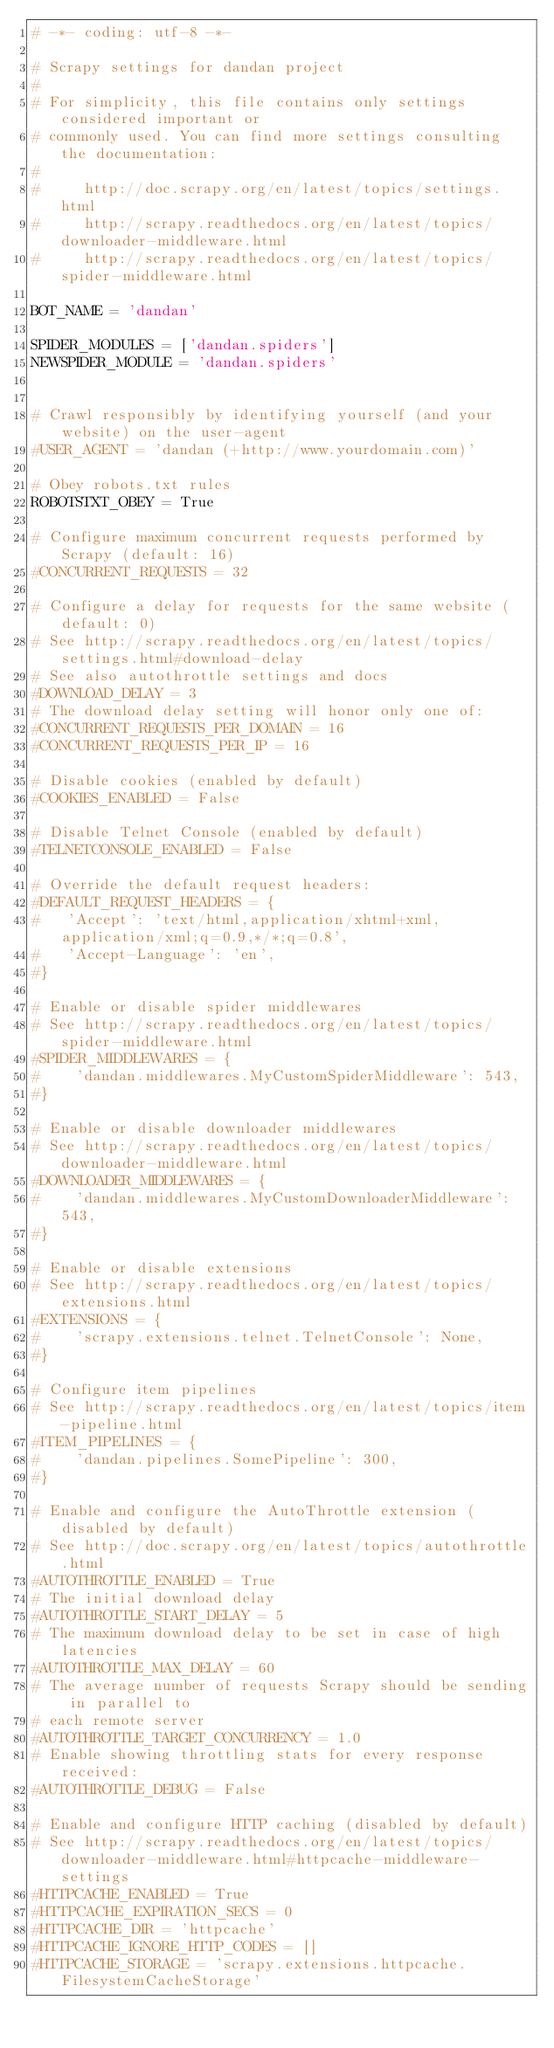Convert code to text. <code><loc_0><loc_0><loc_500><loc_500><_Python_># -*- coding: utf-8 -*-

# Scrapy settings for dandan project
#
# For simplicity, this file contains only settings considered important or
# commonly used. You can find more settings consulting the documentation:
#
#     http://doc.scrapy.org/en/latest/topics/settings.html
#     http://scrapy.readthedocs.org/en/latest/topics/downloader-middleware.html
#     http://scrapy.readthedocs.org/en/latest/topics/spider-middleware.html

BOT_NAME = 'dandan'

SPIDER_MODULES = ['dandan.spiders']
NEWSPIDER_MODULE = 'dandan.spiders'


# Crawl responsibly by identifying yourself (and your website) on the user-agent
#USER_AGENT = 'dandan (+http://www.yourdomain.com)'

# Obey robots.txt rules
ROBOTSTXT_OBEY = True

# Configure maximum concurrent requests performed by Scrapy (default: 16)
#CONCURRENT_REQUESTS = 32

# Configure a delay for requests for the same website (default: 0)
# See http://scrapy.readthedocs.org/en/latest/topics/settings.html#download-delay
# See also autothrottle settings and docs
#DOWNLOAD_DELAY = 3
# The download delay setting will honor only one of:
#CONCURRENT_REQUESTS_PER_DOMAIN = 16
#CONCURRENT_REQUESTS_PER_IP = 16

# Disable cookies (enabled by default)
#COOKIES_ENABLED = False

# Disable Telnet Console (enabled by default)
#TELNETCONSOLE_ENABLED = False

# Override the default request headers:
#DEFAULT_REQUEST_HEADERS = {
#   'Accept': 'text/html,application/xhtml+xml,application/xml;q=0.9,*/*;q=0.8',
#   'Accept-Language': 'en',
#}

# Enable or disable spider middlewares
# See http://scrapy.readthedocs.org/en/latest/topics/spider-middleware.html
#SPIDER_MIDDLEWARES = {
#    'dandan.middlewares.MyCustomSpiderMiddleware': 543,
#}

# Enable or disable downloader middlewares
# See http://scrapy.readthedocs.org/en/latest/topics/downloader-middleware.html
#DOWNLOADER_MIDDLEWARES = {
#    'dandan.middlewares.MyCustomDownloaderMiddleware': 543,
#}

# Enable or disable extensions
# See http://scrapy.readthedocs.org/en/latest/topics/extensions.html
#EXTENSIONS = {
#    'scrapy.extensions.telnet.TelnetConsole': None,
#}

# Configure item pipelines
# See http://scrapy.readthedocs.org/en/latest/topics/item-pipeline.html
#ITEM_PIPELINES = {
#    'dandan.pipelines.SomePipeline': 300,
#}

# Enable and configure the AutoThrottle extension (disabled by default)
# See http://doc.scrapy.org/en/latest/topics/autothrottle.html
#AUTOTHROTTLE_ENABLED = True
# The initial download delay
#AUTOTHROTTLE_START_DELAY = 5
# The maximum download delay to be set in case of high latencies
#AUTOTHROTTLE_MAX_DELAY = 60
# The average number of requests Scrapy should be sending in parallel to
# each remote server
#AUTOTHROTTLE_TARGET_CONCURRENCY = 1.0
# Enable showing throttling stats for every response received:
#AUTOTHROTTLE_DEBUG = False

# Enable and configure HTTP caching (disabled by default)
# See http://scrapy.readthedocs.org/en/latest/topics/downloader-middleware.html#httpcache-middleware-settings
#HTTPCACHE_ENABLED = True
#HTTPCACHE_EXPIRATION_SECS = 0
#HTTPCACHE_DIR = 'httpcache'
#HTTPCACHE_IGNORE_HTTP_CODES = []
#HTTPCACHE_STORAGE = 'scrapy.extensions.httpcache.FilesystemCacheStorage'
</code> 